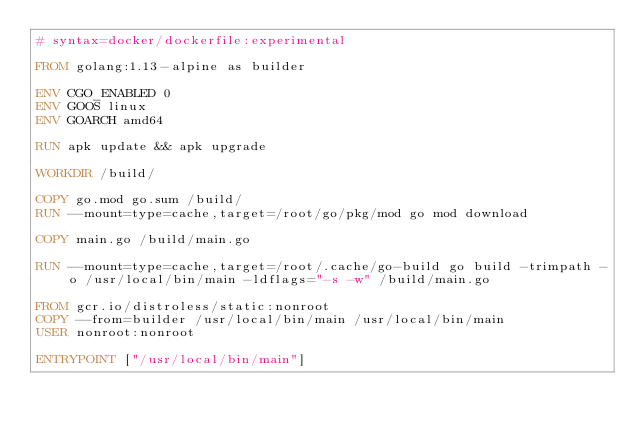Convert code to text. <code><loc_0><loc_0><loc_500><loc_500><_Dockerfile_># syntax=docker/dockerfile:experimental

FROM golang:1.13-alpine as builder

ENV CGO_ENABLED 0
ENV GOOS linux
ENV GOARCH amd64

RUN apk update && apk upgrade

WORKDIR /build/

COPY go.mod go.sum /build/
RUN --mount=type=cache,target=/root/go/pkg/mod go mod download

COPY main.go /build/main.go

RUN --mount=type=cache,target=/root/.cache/go-build go build -trimpath -o /usr/local/bin/main -ldflags="-s -w" /build/main.go

FROM gcr.io/distroless/static:nonroot
COPY --from=builder /usr/local/bin/main /usr/local/bin/main
USER nonroot:nonroot

ENTRYPOINT ["/usr/local/bin/main"]
</code> 